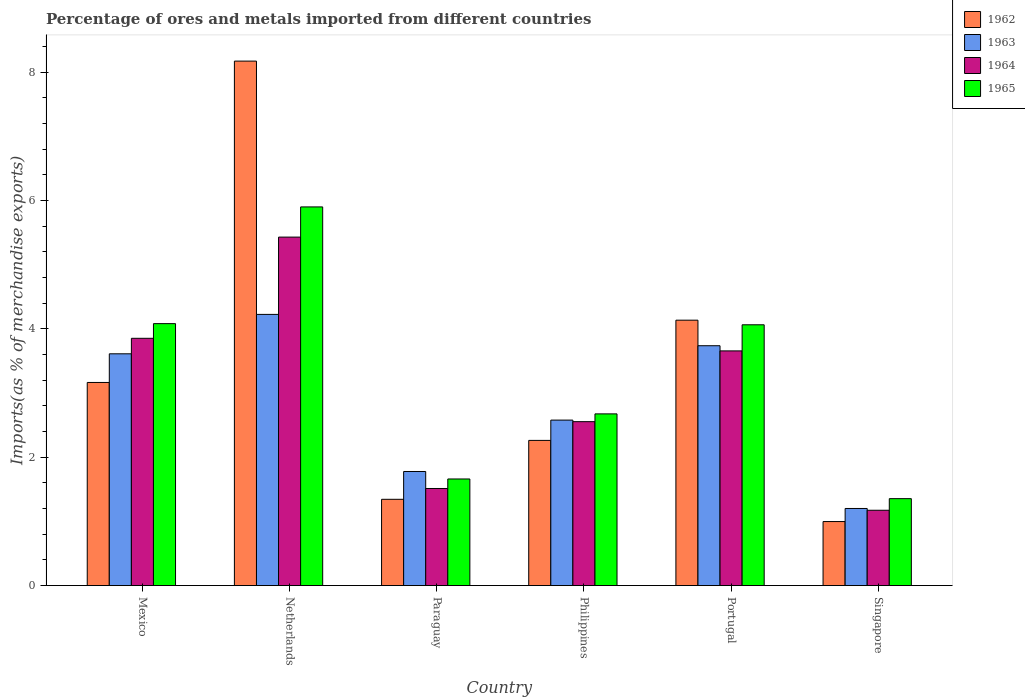How many groups of bars are there?
Your answer should be compact. 6. How many bars are there on the 2nd tick from the left?
Keep it short and to the point. 4. What is the label of the 6th group of bars from the left?
Keep it short and to the point. Singapore. What is the percentage of imports to different countries in 1963 in Mexico?
Your response must be concise. 3.61. Across all countries, what is the maximum percentage of imports to different countries in 1965?
Your answer should be compact. 5.9. Across all countries, what is the minimum percentage of imports to different countries in 1964?
Your answer should be compact. 1.17. In which country was the percentage of imports to different countries in 1965 maximum?
Keep it short and to the point. Netherlands. In which country was the percentage of imports to different countries in 1963 minimum?
Ensure brevity in your answer.  Singapore. What is the total percentage of imports to different countries in 1963 in the graph?
Keep it short and to the point. 17.13. What is the difference between the percentage of imports to different countries in 1964 in Mexico and that in Singapore?
Give a very brief answer. 2.68. What is the difference between the percentage of imports to different countries in 1965 in Netherlands and the percentage of imports to different countries in 1964 in Singapore?
Provide a succinct answer. 4.73. What is the average percentage of imports to different countries in 1965 per country?
Provide a succinct answer. 3.29. What is the difference between the percentage of imports to different countries of/in 1965 and percentage of imports to different countries of/in 1963 in Singapore?
Keep it short and to the point. 0.15. In how many countries, is the percentage of imports to different countries in 1963 greater than 6 %?
Give a very brief answer. 0. What is the ratio of the percentage of imports to different countries in 1964 in Paraguay to that in Singapore?
Make the answer very short. 1.29. Is the percentage of imports to different countries in 1963 in Mexico less than that in Portugal?
Your answer should be compact. Yes. Is the difference between the percentage of imports to different countries in 1965 in Philippines and Singapore greater than the difference between the percentage of imports to different countries in 1963 in Philippines and Singapore?
Make the answer very short. No. What is the difference between the highest and the second highest percentage of imports to different countries in 1964?
Give a very brief answer. -0.2. What is the difference between the highest and the lowest percentage of imports to different countries in 1962?
Make the answer very short. 7.17. What does the 2nd bar from the right in Paraguay represents?
Your response must be concise. 1964. How many bars are there?
Offer a very short reply. 24. Are all the bars in the graph horizontal?
Your answer should be compact. No. Where does the legend appear in the graph?
Offer a terse response. Top right. What is the title of the graph?
Give a very brief answer. Percentage of ores and metals imported from different countries. What is the label or title of the X-axis?
Your response must be concise. Country. What is the label or title of the Y-axis?
Keep it short and to the point. Imports(as % of merchandise exports). What is the Imports(as % of merchandise exports) of 1962 in Mexico?
Your answer should be very brief. 3.16. What is the Imports(as % of merchandise exports) in 1963 in Mexico?
Your response must be concise. 3.61. What is the Imports(as % of merchandise exports) of 1964 in Mexico?
Offer a terse response. 3.85. What is the Imports(as % of merchandise exports) in 1965 in Mexico?
Your response must be concise. 4.08. What is the Imports(as % of merchandise exports) in 1962 in Netherlands?
Give a very brief answer. 8.17. What is the Imports(as % of merchandise exports) in 1963 in Netherlands?
Provide a succinct answer. 4.22. What is the Imports(as % of merchandise exports) in 1964 in Netherlands?
Offer a very short reply. 5.43. What is the Imports(as % of merchandise exports) of 1965 in Netherlands?
Keep it short and to the point. 5.9. What is the Imports(as % of merchandise exports) of 1962 in Paraguay?
Provide a short and direct response. 1.34. What is the Imports(as % of merchandise exports) of 1963 in Paraguay?
Offer a very short reply. 1.78. What is the Imports(as % of merchandise exports) of 1964 in Paraguay?
Your answer should be very brief. 1.51. What is the Imports(as % of merchandise exports) of 1965 in Paraguay?
Your answer should be compact. 1.66. What is the Imports(as % of merchandise exports) of 1962 in Philippines?
Keep it short and to the point. 2.26. What is the Imports(as % of merchandise exports) of 1963 in Philippines?
Your answer should be compact. 2.58. What is the Imports(as % of merchandise exports) in 1964 in Philippines?
Make the answer very short. 2.55. What is the Imports(as % of merchandise exports) in 1965 in Philippines?
Provide a short and direct response. 2.67. What is the Imports(as % of merchandise exports) of 1962 in Portugal?
Your answer should be very brief. 4.13. What is the Imports(as % of merchandise exports) in 1963 in Portugal?
Offer a very short reply. 3.74. What is the Imports(as % of merchandise exports) of 1964 in Portugal?
Your answer should be very brief. 3.66. What is the Imports(as % of merchandise exports) in 1965 in Portugal?
Offer a very short reply. 4.06. What is the Imports(as % of merchandise exports) of 1962 in Singapore?
Offer a very short reply. 1. What is the Imports(as % of merchandise exports) of 1963 in Singapore?
Offer a very short reply. 1.2. What is the Imports(as % of merchandise exports) of 1964 in Singapore?
Give a very brief answer. 1.17. What is the Imports(as % of merchandise exports) in 1965 in Singapore?
Your answer should be compact. 1.35. Across all countries, what is the maximum Imports(as % of merchandise exports) of 1962?
Your response must be concise. 8.17. Across all countries, what is the maximum Imports(as % of merchandise exports) in 1963?
Provide a short and direct response. 4.22. Across all countries, what is the maximum Imports(as % of merchandise exports) of 1964?
Give a very brief answer. 5.43. Across all countries, what is the maximum Imports(as % of merchandise exports) in 1965?
Your answer should be very brief. 5.9. Across all countries, what is the minimum Imports(as % of merchandise exports) in 1962?
Ensure brevity in your answer.  1. Across all countries, what is the minimum Imports(as % of merchandise exports) of 1963?
Ensure brevity in your answer.  1.2. Across all countries, what is the minimum Imports(as % of merchandise exports) in 1964?
Keep it short and to the point. 1.17. Across all countries, what is the minimum Imports(as % of merchandise exports) of 1965?
Keep it short and to the point. 1.35. What is the total Imports(as % of merchandise exports) in 1962 in the graph?
Ensure brevity in your answer.  20.07. What is the total Imports(as % of merchandise exports) of 1963 in the graph?
Offer a terse response. 17.13. What is the total Imports(as % of merchandise exports) in 1964 in the graph?
Your answer should be very brief. 18.18. What is the total Imports(as % of merchandise exports) in 1965 in the graph?
Make the answer very short. 19.73. What is the difference between the Imports(as % of merchandise exports) of 1962 in Mexico and that in Netherlands?
Keep it short and to the point. -5.01. What is the difference between the Imports(as % of merchandise exports) of 1963 in Mexico and that in Netherlands?
Make the answer very short. -0.61. What is the difference between the Imports(as % of merchandise exports) of 1964 in Mexico and that in Netherlands?
Ensure brevity in your answer.  -1.58. What is the difference between the Imports(as % of merchandise exports) in 1965 in Mexico and that in Netherlands?
Your answer should be very brief. -1.82. What is the difference between the Imports(as % of merchandise exports) of 1962 in Mexico and that in Paraguay?
Offer a terse response. 1.82. What is the difference between the Imports(as % of merchandise exports) in 1963 in Mexico and that in Paraguay?
Your answer should be compact. 1.83. What is the difference between the Imports(as % of merchandise exports) in 1964 in Mexico and that in Paraguay?
Your response must be concise. 2.34. What is the difference between the Imports(as % of merchandise exports) in 1965 in Mexico and that in Paraguay?
Your answer should be very brief. 2.42. What is the difference between the Imports(as % of merchandise exports) in 1962 in Mexico and that in Philippines?
Ensure brevity in your answer.  0.9. What is the difference between the Imports(as % of merchandise exports) of 1963 in Mexico and that in Philippines?
Your answer should be compact. 1.03. What is the difference between the Imports(as % of merchandise exports) in 1964 in Mexico and that in Philippines?
Provide a short and direct response. 1.3. What is the difference between the Imports(as % of merchandise exports) in 1965 in Mexico and that in Philippines?
Make the answer very short. 1.41. What is the difference between the Imports(as % of merchandise exports) of 1962 in Mexico and that in Portugal?
Your answer should be compact. -0.97. What is the difference between the Imports(as % of merchandise exports) in 1963 in Mexico and that in Portugal?
Your answer should be compact. -0.13. What is the difference between the Imports(as % of merchandise exports) in 1964 in Mexico and that in Portugal?
Offer a very short reply. 0.2. What is the difference between the Imports(as % of merchandise exports) of 1965 in Mexico and that in Portugal?
Give a very brief answer. 0.02. What is the difference between the Imports(as % of merchandise exports) of 1962 in Mexico and that in Singapore?
Your answer should be very brief. 2.17. What is the difference between the Imports(as % of merchandise exports) of 1963 in Mexico and that in Singapore?
Give a very brief answer. 2.41. What is the difference between the Imports(as % of merchandise exports) of 1964 in Mexico and that in Singapore?
Your answer should be very brief. 2.68. What is the difference between the Imports(as % of merchandise exports) of 1965 in Mexico and that in Singapore?
Your answer should be very brief. 2.73. What is the difference between the Imports(as % of merchandise exports) of 1962 in Netherlands and that in Paraguay?
Provide a succinct answer. 6.83. What is the difference between the Imports(as % of merchandise exports) in 1963 in Netherlands and that in Paraguay?
Give a very brief answer. 2.45. What is the difference between the Imports(as % of merchandise exports) in 1964 in Netherlands and that in Paraguay?
Make the answer very short. 3.92. What is the difference between the Imports(as % of merchandise exports) in 1965 in Netherlands and that in Paraguay?
Your response must be concise. 4.24. What is the difference between the Imports(as % of merchandise exports) of 1962 in Netherlands and that in Philippines?
Your answer should be very brief. 5.91. What is the difference between the Imports(as % of merchandise exports) in 1963 in Netherlands and that in Philippines?
Give a very brief answer. 1.65. What is the difference between the Imports(as % of merchandise exports) of 1964 in Netherlands and that in Philippines?
Make the answer very short. 2.88. What is the difference between the Imports(as % of merchandise exports) of 1965 in Netherlands and that in Philippines?
Provide a short and direct response. 3.22. What is the difference between the Imports(as % of merchandise exports) of 1962 in Netherlands and that in Portugal?
Give a very brief answer. 4.04. What is the difference between the Imports(as % of merchandise exports) of 1963 in Netherlands and that in Portugal?
Ensure brevity in your answer.  0.49. What is the difference between the Imports(as % of merchandise exports) of 1964 in Netherlands and that in Portugal?
Make the answer very short. 1.77. What is the difference between the Imports(as % of merchandise exports) in 1965 in Netherlands and that in Portugal?
Make the answer very short. 1.84. What is the difference between the Imports(as % of merchandise exports) of 1962 in Netherlands and that in Singapore?
Offer a terse response. 7.17. What is the difference between the Imports(as % of merchandise exports) in 1963 in Netherlands and that in Singapore?
Your response must be concise. 3.02. What is the difference between the Imports(as % of merchandise exports) in 1964 in Netherlands and that in Singapore?
Make the answer very short. 4.26. What is the difference between the Imports(as % of merchandise exports) of 1965 in Netherlands and that in Singapore?
Provide a short and direct response. 4.55. What is the difference between the Imports(as % of merchandise exports) of 1962 in Paraguay and that in Philippines?
Provide a short and direct response. -0.92. What is the difference between the Imports(as % of merchandise exports) in 1963 in Paraguay and that in Philippines?
Keep it short and to the point. -0.8. What is the difference between the Imports(as % of merchandise exports) in 1964 in Paraguay and that in Philippines?
Your answer should be very brief. -1.04. What is the difference between the Imports(as % of merchandise exports) in 1965 in Paraguay and that in Philippines?
Your answer should be compact. -1.01. What is the difference between the Imports(as % of merchandise exports) of 1962 in Paraguay and that in Portugal?
Make the answer very short. -2.79. What is the difference between the Imports(as % of merchandise exports) in 1963 in Paraguay and that in Portugal?
Offer a terse response. -1.96. What is the difference between the Imports(as % of merchandise exports) in 1964 in Paraguay and that in Portugal?
Provide a short and direct response. -2.14. What is the difference between the Imports(as % of merchandise exports) of 1965 in Paraguay and that in Portugal?
Ensure brevity in your answer.  -2.4. What is the difference between the Imports(as % of merchandise exports) in 1962 in Paraguay and that in Singapore?
Ensure brevity in your answer.  0.35. What is the difference between the Imports(as % of merchandise exports) of 1963 in Paraguay and that in Singapore?
Your answer should be very brief. 0.58. What is the difference between the Imports(as % of merchandise exports) of 1964 in Paraguay and that in Singapore?
Your response must be concise. 0.34. What is the difference between the Imports(as % of merchandise exports) of 1965 in Paraguay and that in Singapore?
Offer a very short reply. 0.31. What is the difference between the Imports(as % of merchandise exports) of 1962 in Philippines and that in Portugal?
Provide a short and direct response. -1.87. What is the difference between the Imports(as % of merchandise exports) in 1963 in Philippines and that in Portugal?
Ensure brevity in your answer.  -1.16. What is the difference between the Imports(as % of merchandise exports) of 1964 in Philippines and that in Portugal?
Offer a very short reply. -1.1. What is the difference between the Imports(as % of merchandise exports) in 1965 in Philippines and that in Portugal?
Offer a very short reply. -1.39. What is the difference between the Imports(as % of merchandise exports) of 1962 in Philippines and that in Singapore?
Offer a terse response. 1.26. What is the difference between the Imports(as % of merchandise exports) of 1963 in Philippines and that in Singapore?
Offer a terse response. 1.38. What is the difference between the Imports(as % of merchandise exports) of 1964 in Philippines and that in Singapore?
Provide a short and direct response. 1.38. What is the difference between the Imports(as % of merchandise exports) of 1965 in Philippines and that in Singapore?
Give a very brief answer. 1.32. What is the difference between the Imports(as % of merchandise exports) in 1962 in Portugal and that in Singapore?
Offer a very short reply. 3.14. What is the difference between the Imports(as % of merchandise exports) of 1963 in Portugal and that in Singapore?
Your answer should be compact. 2.54. What is the difference between the Imports(as % of merchandise exports) in 1964 in Portugal and that in Singapore?
Offer a very short reply. 2.48. What is the difference between the Imports(as % of merchandise exports) in 1965 in Portugal and that in Singapore?
Your response must be concise. 2.71. What is the difference between the Imports(as % of merchandise exports) in 1962 in Mexico and the Imports(as % of merchandise exports) in 1963 in Netherlands?
Your response must be concise. -1.06. What is the difference between the Imports(as % of merchandise exports) in 1962 in Mexico and the Imports(as % of merchandise exports) in 1964 in Netherlands?
Make the answer very short. -2.26. What is the difference between the Imports(as % of merchandise exports) of 1962 in Mexico and the Imports(as % of merchandise exports) of 1965 in Netherlands?
Your answer should be compact. -2.73. What is the difference between the Imports(as % of merchandise exports) of 1963 in Mexico and the Imports(as % of merchandise exports) of 1964 in Netherlands?
Your response must be concise. -1.82. What is the difference between the Imports(as % of merchandise exports) of 1963 in Mexico and the Imports(as % of merchandise exports) of 1965 in Netherlands?
Offer a terse response. -2.29. What is the difference between the Imports(as % of merchandise exports) of 1964 in Mexico and the Imports(as % of merchandise exports) of 1965 in Netherlands?
Your answer should be very brief. -2.05. What is the difference between the Imports(as % of merchandise exports) of 1962 in Mexico and the Imports(as % of merchandise exports) of 1963 in Paraguay?
Keep it short and to the point. 1.39. What is the difference between the Imports(as % of merchandise exports) in 1962 in Mexico and the Imports(as % of merchandise exports) in 1964 in Paraguay?
Your answer should be compact. 1.65. What is the difference between the Imports(as % of merchandise exports) of 1962 in Mexico and the Imports(as % of merchandise exports) of 1965 in Paraguay?
Make the answer very short. 1.5. What is the difference between the Imports(as % of merchandise exports) in 1963 in Mexico and the Imports(as % of merchandise exports) in 1964 in Paraguay?
Give a very brief answer. 2.1. What is the difference between the Imports(as % of merchandise exports) in 1963 in Mexico and the Imports(as % of merchandise exports) in 1965 in Paraguay?
Your answer should be compact. 1.95. What is the difference between the Imports(as % of merchandise exports) of 1964 in Mexico and the Imports(as % of merchandise exports) of 1965 in Paraguay?
Provide a succinct answer. 2.19. What is the difference between the Imports(as % of merchandise exports) of 1962 in Mexico and the Imports(as % of merchandise exports) of 1963 in Philippines?
Keep it short and to the point. 0.59. What is the difference between the Imports(as % of merchandise exports) of 1962 in Mexico and the Imports(as % of merchandise exports) of 1964 in Philippines?
Provide a succinct answer. 0.61. What is the difference between the Imports(as % of merchandise exports) in 1962 in Mexico and the Imports(as % of merchandise exports) in 1965 in Philippines?
Make the answer very short. 0.49. What is the difference between the Imports(as % of merchandise exports) in 1963 in Mexico and the Imports(as % of merchandise exports) in 1964 in Philippines?
Keep it short and to the point. 1.06. What is the difference between the Imports(as % of merchandise exports) of 1963 in Mexico and the Imports(as % of merchandise exports) of 1965 in Philippines?
Give a very brief answer. 0.94. What is the difference between the Imports(as % of merchandise exports) in 1964 in Mexico and the Imports(as % of merchandise exports) in 1965 in Philippines?
Make the answer very short. 1.18. What is the difference between the Imports(as % of merchandise exports) of 1962 in Mexico and the Imports(as % of merchandise exports) of 1963 in Portugal?
Give a very brief answer. -0.57. What is the difference between the Imports(as % of merchandise exports) of 1962 in Mexico and the Imports(as % of merchandise exports) of 1964 in Portugal?
Provide a short and direct response. -0.49. What is the difference between the Imports(as % of merchandise exports) in 1962 in Mexico and the Imports(as % of merchandise exports) in 1965 in Portugal?
Your response must be concise. -0.9. What is the difference between the Imports(as % of merchandise exports) of 1963 in Mexico and the Imports(as % of merchandise exports) of 1964 in Portugal?
Provide a short and direct response. -0.05. What is the difference between the Imports(as % of merchandise exports) in 1963 in Mexico and the Imports(as % of merchandise exports) in 1965 in Portugal?
Make the answer very short. -0.45. What is the difference between the Imports(as % of merchandise exports) in 1964 in Mexico and the Imports(as % of merchandise exports) in 1965 in Portugal?
Your response must be concise. -0.21. What is the difference between the Imports(as % of merchandise exports) in 1962 in Mexico and the Imports(as % of merchandise exports) in 1963 in Singapore?
Your answer should be very brief. 1.96. What is the difference between the Imports(as % of merchandise exports) in 1962 in Mexico and the Imports(as % of merchandise exports) in 1964 in Singapore?
Offer a very short reply. 1.99. What is the difference between the Imports(as % of merchandise exports) of 1962 in Mexico and the Imports(as % of merchandise exports) of 1965 in Singapore?
Offer a terse response. 1.81. What is the difference between the Imports(as % of merchandise exports) of 1963 in Mexico and the Imports(as % of merchandise exports) of 1964 in Singapore?
Offer a terse response. 2.44. What is the difference between the Imports(as % of merchandise exports) of 1963 in Mexico and the Imports(as % of merchandise exports) of 1965 in Singapore?
Ensure brevity in your answer.  2.26. What is the difference between the Imports(as % of merchandise exports) in 1964 in Mexico and the Imports(as % of merchandise exports) in 1965 in Singapore?
Ensure brevity in your answer.  2.5. What is the difference between the Imports(as % of merchandise exports) in 1962 in Netherlands and the Imports(as % of merchandise exports) in 1963 in Paraguay?
Offer a terse response. 6.39. What is the difference between the Imports(as % of merchandise exports) in 1962 in Netherlands and the Imports(as % of merchandise exports) in 1964 in Paraguay?
Provide a succinct answer. 6.66. What is the difference between the Imports(as % of merchandise exports) in 1962 in Netherlands and the Imports(as % of merchandise exports) in 1965 in Paraguay?
Provide a short and direct response. 6.51. What is the difference between the Imports(as % of merchandise exports) in 1963 in Netherlands and the Imports(as % of merchandise exports) in 1964 in Paraguay?
Offer a terse response. 2.71. What is the difference between the Imports(as % of merchandise exports) in 1963 in Netherlands and the Imports(as % of merchandise exports) in 1965 in Paraguay?
Make the answer very short. 2.56. What is the difference between the Imports(as % of merchandise exports) in 1964 in Netherlands and the Imports(as % of merchandise exports) in 1965 in Paraguay?
Keep it short and to the point. 3.77. What is the difference between the Imports(as % of merchandise exports) in 1962 in Netherlands and the Imports(as % of merchandise exports) in 1963 in Philippines?
Your answer should be very brief. 5.59. What is the difference between the Imports(as % of merchandise exports) in 1962 in Netherlands and the Imports(as % of merchandise exports) in 1964 in Philippines?
Provide a succinct answer. 5.62. What is the difference between the Imports(as % of merchandise exports) of 1962 in Netherlands and the Imports(as % of merchandise exports) of 1965 in Philippines?
Offer a very short reply. 5.5. What is the difference between the Imports(as % of merchandise exports) of 1963 in Netherlands and the Imports(as % of merchandise exports) of 1964 in Philippines?
Offer a very short reply. 1.67. What is the difference between the Imports(as % of merchandise exports) of 1963 in Netherlands and the Imports(as % of merchandise exports) of 1965 in Philippines?
Offer a very short reply. 1.55. What is the difference between the Imports(as % of merchandise exports) of 1964 in Netherlands and the Imports(as % of merchandise exports) of 1965 in Philippines?
Your answer should be compact. 2.75. What is the difference between the Imports(as % of merchandise exports) in 1962 in Netherlands and the Imports(as % of merchandise exports) in 1963 in Portugal?
Give a very brief answer. 4.43. What is the difference between the Imports(as % of merchandise exports) in 1962 in Netherlands and the Imports(as % of merchandise exports) in 1964 in Portugal?
Your response must be concise. 4.51. What is the difference between the Imports(as % of merchandise exports) of 1962 in Netherlands and the Imports(as % of merchandise exports) of 1965 in Portugal?
Your response must be concise. 4.11. What is the difference between the Imports(as % of merchandise exports) in 1963 in Netherlands and the Imports(as % of merchandise exports) in 1964 in Portugal?
Your answer should be very brief. 0.57. What is the difference between the Imports(as % of merchandise exports) in 1963 in Netherlands and the Imports(as % of merchandise exports) in 1965 in Portugal?
Your answer should be very brief. 0.16. What is the difference between the Imports(as % of merchandise exports) of 1964 in Netherlands and the Imports(as % of merchandise exports) of 1965 in Portugal?
Make the answer very short. 1.37. What is the difference between the Imports(as % of merchandise exports) of 1962 in Netherlands and the Imports(as % of merchandise exports) of 1963 in Singapore?
Your answer should be very brief. 6.97. What is the difference between the Imports(as % of merchandise exports) of 1962 in Netherlands and the Imports(as % of merchandise exports) of 1964 in Singapore?
Give a very brief answer. 7. What is the difference between the Imports(as % of merchandise exports) in 1962 in Netherlands and the Imports(as % of merchandise exports) in 1965 in Singapore?
Ensure brevity in your answer.  6.82. What is the difference between the Imports(as % of merchandise exports) of 1963 in Netherlands and the Imports(as % of merchandise exports) of 1964 in Singapore?
Ensure brevity in your answer.  3.05. What is the difference between the Imports(as % of merchandise exports) in 1963 in Netherlands and the Imports(as % of merchandise exports) in 1965 in Singapore?
Your answer should be compact. 2.87. What is the difference between the Imports(as % of merchandise exports) of 1964 in Netherlands and the Imports(as % of merchandise exports) of 1965 in Singapore?
Provide a short and direct response. 4.07. What is the difference between the Imports(as % of merchandise exports) of 1962 in Paraguay and the Imports(as % of merchandise exports) of 1963 in Philippines?
Make the answer very short. -1.23. What is the difference between the Imports(as % of merchandise exports) of 1962 in Paraguay and the Imports(as % of merchandise exports) of 1964 in Philippines?
Your answer should be very brief. -1.21. What is the difference between the Imports(as % of merchandise exports) of 1962 in Paraguay and the Imports(as % of merchandise exports) of 1965 in Philippines?
Give a very brief answer. -1.33. What is the difference between the Imports(as % of merchandise exports) of 1963 in Paraguay and the Imports(as % of merchandise exports) of 1964 in Philippines?
Your response must be concise. -0.78. What is the difference between the Imports(as % of merchandise exports) of 1963 in Paraguay and the Imports(as % of merchandise exports) of 1965 in Philippines?
Provide a short and direct response. -0.9. What is the difference between the Imports(as % of merchandise exports) in 1964 in Paraguay and the Imports(as % of merchandise exports) in 1965 in Philippines?
Make the answer very short. -1.16. What is the difference between the Imports(as % of merchandise exports) in 1962 in Paraguay and the Imports(as % of merchandise exports) in 1963 in Portugal?
Your answer should be compact. -2.39. What is the difference between the Imports(as % of merchandise exports) of 1962 in Paraguay and the Imports(as % of merchandise exports) of 1964 in Portugal?
Make the answer very short. -2.31. What is the difference between the Imports(as % of merchandise exports) in 1962 in Paraguay and the Imports(as % of merchandise exports) in 1965 in Portugal?
Your response must be concise. -2.72. What is the difference between the Imports(as % of merchandise exports) in 1963 in Paraguay and the Imports(as % of merchandise exports) in 1964 in Portugal?
Ensure brevity in your answer.  -1.88. What is the difference between the Imports(as % of merchandise exports) in 1963 in Paraguay and the Imports(as % of merchandise exports) in 1965 in Portugal?
Provide a short and direct response. -2.29. What is the difference between the Imports(as % of merchandise exports) in 1964 in Paraguay and the Imports(as % of merchandise exports) in 1965 in Portugal?
Your answer should be very brief. -2.55. What is the difference between the Imports(as % of merchandise exports) of 1962 in Paraguay and the Imports(as % of merchandise exports) of 1963 in Singapore?
Offer a terse response. 0.14. What is the difference between the Imports(as % of merchandise exports) in 1962 in Paraguay and the Imports(as % of merchandise exports) in 1964 in Singapore?
Ensure brevity in your answer.  0.17. What is the difference between the Imports(as % of merchandise exports) of 1962 in Paraguay and the Imports(as % of merchandise exports) of 1965 in Singapore?
Provide a succinct answer. -0.01. What is the difference between the Imports(as % of merchandise exports) of 1963 in Paraguay and the Imports(as % of merchandise exports) of 1964 in Singapore?
Your response must be concise. 0.6. What is the difference between the Imports(as % of merchandise exports) in 1963 in Paraguay and the Imports(as % of merchandise exports) in 1965 in Singapore?
Ensure brevity in your answer.  0.42. What is the difference between the Imports(as % of merchandise exports) in 1964 in Paraguay and the Imports(as % of merchandise exports) in 1965 in Singapore?
Offer a very short reply. 0.16. What is the difference between the Imports(as % of merchandise exports) of 1962 in Philippines and the Imports(as % of merchandise exports) of 1963 in Portugal?
Your response must be concise. -1.47. What is the difference between the Imports(as % of merchandise exports) in 1962 in Philippines and the Imports(as % of merchandise exports) in 1964 in Portugal?
Your answer should be very brief. -1.39. What is the difference between the Imports(as % of merchandise exports) of 1962 in Philippines and the Imports(as % of merchandise exports) of 1965 in Portugal?
Provide a succinct answer. -1.8. What is the difference between the Imports(as % of merchandise exports) of 1963 in Philippines and the Imports(as % of merchandise exports) of 1964 in Portugal?
Give a very brief answer. -1.08. What is the difference between the Imports(as % of merchandise exports) in 1963 in Philippines and the Imports(as % of merchandise exports) in 1965 in Portugal?
Your response must be concise. -1.48. What is the difference between the Imports(as % of merchandise exports) in 1964 in Philippines and the Imports(as % of merchandise exports) in 1965 in Portugal?
Make the answer very short. -1.51. What is the difference between the Imports(as % of merchandise exports) of 1962 in Philippines and the Imports(as % of merchandise exports) of 1963 in Singapore?
Offer a very short reply. 1.06. What is the difference between the Imports(as % of merchandise exports) of 1962 in Philippines and the Imports(as % of merchandise exports) of 1964 in Singapore?
Ensure brevity in your answer.  1.09. What is the difference between the Imports(as % of merchandise exports) of 1962 in Philippines and the Imports(as % of merchandise exports) of 1965 in Singapore?
Make the answer very short. 0.91. What is the difference between the Imports(as % of merchandise exports) of 1963 in Philippines and the Imports(as % of merchandise exports) of 1964 in Singapore?
Your answer should be very brief. 1.4. What is the difference between the Imports(as % of merchandise exports) in 1963 in Philippines and the Imports(as % of merchandise exports) in 1965 in Singapore?
Your answer should be very brief. 1.22. What is the difference between the Imports(as % of merchandise exports) in 1964 in Philippines and the Imports(as % of merchandise exports) in 1965 in Singapore?
Your answer should be compact. 1.2. What is the difference between the Imports(as % of merchandise exports) of 1962 in Portugal and the Imports(as % of merchandise exports) of 1963 in Singapore?
Ensure brevity in your answer.  2.93. What is the difference between the Imports(as % of merchandise exports) in 1962 in Portugal and the Imports(as % of merchandise exports) in 1964 in Singapore?
Your response must be concise. 2.96. What is the difference between the Imports(as % of merchandise exports) of 1962 in Portugal and the Imports(as % of merchandise exports) of 1965 in Singapore?
Ensure brevity in your answer.  2.78. What is the difference between the Imports(as % of merchandise exports) of 1963 in Portugal and the Imports(as % of merchandise exports) of 1964 in Singapore?
Give a very brief answer. 2.56. What is the difference between the Imports(as % of merchandise exports) in 1963 in Portugal and the Imports(as % of merchandise exports) in 1965 in Singapore?
Offer a very short reply. 2.38. What is the difference between the Imports(as % of merchandise exports) of 1964 in Portugal and the Imports(as % of merchandise exports) of 1965 in Singapore?
Offer a very short reply. 2.3. What is the average Imports(as % of merchandise exports) of 1962 per country?
Keep it short and to the point. 3.35. What is the average Imports(as % of merchandise exports) of 1963 per country?
Make the answer very short. 2.85. What is the average Imports(as % of merchandise exports) in 1964 per country?
Your answer should be very brief. 3.03. What is the average Imports(as % of merchandise exports) in 1965 per country?
Give a very brief answer. 3.29. What is the difference between the Imports(as % of merchandise exports) in 1962 and Imports(as % of merchandise exports) in 1963 in Mexico?
Keep it short and to the point. -0.45. What is the difference between the Imports(as % of merchandise exports) in 1962 and Imports(as % of merchandise exports) in 1964 in Mexico?
Provide a short and direct response. -0.69. What is the difference between the Imports(as % of merchandise exports) of 1962 and Imports(as % of merchandise exports) of 1965 in Mexico?
Your answer should be compact. -0.92. What is the difference between the Imports(as % of merchandise exports) in 1963 and Imports(as % of merchandise exports) in 1964 in Mexico?
Your answer should be compact. -0.24. What is the difference between the Imports(as % of merchandise exports) in 1963 and Imports(as % of merchandise exports) in 1965 in Mexico?
Ensure brevity in your answer.  -0.47. What is the difference between the Imports(as % of merchandise exports) of 1964 and Imports(as % of merchandise exports) of 1965 in Mexico?
Your response must be concise. -0.23. What is the difference between the Imports(as % of merchandise exports) in 1962 and Imports(as % of merchandise exports) in 1963 in Netherlands?
Your answer should be very brief. 3.95. What is the difference between the Imports(as % of merchandise exports) in 1962 and Imports(as % of merchandise exports) in 1964 in Netherlands?
Make the answer very short. 2.74. What is the difference between the Imports(as % of merchandise exports) in 1962 and Imports(as % of merchandise exports) in 1965 in Netherlands?
Your answer should be very brief. 2.27. What is the difference between the Imports(as % of merchandise exports) of 1963 and Imports(as % of merchandise exports) of 1964 in Netherlands?
Give a very brief answer. -1.2. What is the difference between the Imports(as % of merchandise exports) in 1963 and Imports(as % of merchandise exports) in 1965 in Netherlands?
Offer a terse response. -1.67. What is the difference between the Imports(as % of merchandise exports) in 1964 and Imports(as % of merchandise exports) in 1965 in Netherlands?
Make the answer very short. -0.47. What is the difference between the Imports(as % of merchandise exports) of 1962 and Imports(as % of merchandise exports) of 1963 in Paraguay?
Your answer should be very brief. -0.43. What is the difference between the Imports(as % of merchandise exports) of 1962 and Imports(as % of merchandise exports) of 1964 in Paraguay?
Make the answer very short. -0.17. What is the difference between the Imports(as % of merchandise exports) in 1962 and Imports(as % of merchandise exports) in 1965 in Paraguay?
Provide a succinct answer. -0.32. What is the difference between the Imports(as % of merchandise exports) of 1963 and Imports(as % of merchandise exports) of 1964 in Paraguay?
Offer a terse response. 0.26. What is the difference between the Imports(as % of merchandise exports) of 1963 and Imports(as % of merchandise exports) of 1965 in Paraguay?
Provide a short and direct response. 0.12. What is the difference between the Imports(as % of merchandise exports) in 1964 and Imports(as % of merchandise exports) in 1965 in Paraguay?
Your answer should be very brief. -0.15. What is the difference between the Imports(as % of merchandise exports) of 1962 and Imports(as % of merchandise exports) of 1963 in Philippines?
Offer a very short reply. -0.32. What is the difference between the Imports(as % of merchandise exports) in 1962 and Imports(as % of merchandise exports) in 1964 in Philippines?
Your answer should be very brief. -0.29. What is the difference between the Imports(as % of merchandise exports) in 1962 and Imports(as % of merchandise exports) in 1965 in Philippines?
Your response must be concise. -0.41. What is the difference between the Imports(as % of merchandise exports) in 1963 and Imports(as % of merchandise exports) in 1964 in Philippines?
Keep it short and to the point. 0.02. What is the difference between the Imports(as % of merchandise exports) in 1963 and Imports(as % of merchandise exports) in 1965 in Philippines?
Offer a terse response. -0.1. What is the difference between the Imports(as % of merchandise exports) in 1964 and Imports(as % of merchandise exports) in 1965 in Philippines?
Your response must be concise. -0.12. What is the difference between the Imports(as % of merchandise exports) of 1962 and Imports(as % of merchandise exports) of 1963 in Portugal?
Ensure brevity in your answer.  0.4. What is the difference between the Imports(as % of merchandise exports) of 1962 and Imports(as % of merchandise exports) of 1964 in Portugal?
Provide a short and direct response. 0.48. What is the difference between the Imports(as % of merchandise exports) in 1962 and Imports(as % of merchandise exports) in 1965 in Portugal?
Make the answer very short. 0.07. What is the difference between the Imports(as % of merchandise exports) in 1963 and Imports(as % of merchandise exports) in 1964 in Portugal?
Keep it short and to the point. 0.08. What is the difference between the Imports(as % of merchandise exports) of 1963 and Imports(as % of merchandise exports) of 1965 in Portugal?
Offer a very short reply. -0.33. What is the difference between the Imports(as % of merchandise exports) in 1964 and Imports(as % of merchandise exports) in 1965 in Portugal?
Your answer should be very brief. -0.41. What is the difference between the Imports(as % of merchandise exports) in 1962 and Imports(as % of merchandise exports) in 1963 in Singapore?
Keep it short and to the point. -0.2. What is the difference between the Imports(as % of merchandise exports) of 1962 and Imports(as % of merchandise exports) of 1964 in Singapore?
Your answer should be compact. -0.18. What is the difference between the Imports(as % of merchandise exports) of 1962 and Imports(as % of merchandise exports) of 1965 in Singapore?
Provide a succinct answer. -0.36. What is the difference between the Imports(as % of merchandise exports) of 1963 and Imports(as % of merchandise exports) of 1964 in Singapore?
Make the answer very short. 0.03. What is the difference between the Imports(as % of merchandise exports) of 1963 and Imports(as % of merchandise exports) of 1965 in Singapore?
Your response must be concise. -0.15. What is the difference between the Imports(as % of merchandise exports) in 1964 and Imports(as % of merchandise exports) in 1965 in Singapore?
Make the answer very short. -0.18. What is the ratio of the Imports(as % of merchandise exports) in 1962 in Mexico to that in Netherlands?
Your answer should be compact. 0.39. What is the ratio of the Imports(as % of merchandise exports) of 1963 in Mexico to that in Netherlands?
Your answer should be compact. 0.85. What is the ratio of the Imports(as % of merchandise exports) of 1964 in Mexico to that in Netherlands?
Your answer should be compact. 0.71. What is the ratio of the Imports(as % of merchandise exports) of 1965 in Mexico to that in Netherlands?
Make the answer very short. 0.69. What is the ratio of the Imports(as % of merchandise exports) in 1962 in Mexico to that in Paraguay?
Keep it short and to the point. 2.35. What is the ratio of the Imports(as % of merchandise exports) of 1963 in Mexico to that in Paraguay?
Your response must be concise. 2.03. What is the ratio of the Imports(as % of merchandise exports) of 1964 in Mexico to that in Paraguay?
Give a very brief answer. 2.55. What is the ratio of the Imports(as % of merchandise exports) in 1965 in Mexico to that in Paraguay?
Provide a short and direct response. 2.46. What is the ratio of the Imports(as % of merchandise exports) in 1962 in Mexico to that in Philippines?
Your answer should be very brief. 1.4. What is the ratio of the Imports(as % of merchandise exports) in 1963 in Mexico to that in Philippines?
Your response must be concise. 1.4. What is the ratio of the Imports(as % of merchandise exports) in 1964 in Mexico to that in Philippines?
Provide a succinct answer. 1.51. What is the ratio of the Imports(as % of merchandise exports) in 1965 in Mexico to that in Philippines?
Give a very brief answer. 1.53. What is the ratio of the Imports(as % of merchandise exports) of 1962 in Mexico to that in Portugal?
Provide a short and direct response. 0.77. What is the ratio of the Imports(as % of merchandise exports) in 1963 in Mexico to that in Portugal?
Provide a succinct answer. 0.97. What is the ratio of the Imports(as % of merchandise exports) of 1964 in Mexico to that in Portugal?
Provide a short and direct response. 1.05. What is the ratio of the Imports(as % of merchandise exports) of 1962 in Mexico to that in Singapore?
Ensure brevity in your answer.  3.17. What is the ratio of the Imports(as % of merchandise exports) of 1963 in Mexico to that in Singapore?
Make the answer very short. 3.01. What is the ratio of the Imports(as % of merchandise exports) in 1964 in Mexico to that in Singapore?
Keep it short and to the point. 3.28. What is the ratio of the Imports(as % of merchandise exports) in 1965 in Mexico to that in Singapore?
Your answer should be very brief. 3.01. What is the ratio of the Imports(as % of merchandise exports) of 1962 in Netherlands to that in Paraguay?
Ensure brevity in your answer.  6.08. What is the ratio of the Imports(as % of merchandise exports) in 1963 in Netherlands to that in Paraguay?
Provide a succinct answer. 2.38. What is the ratio of the Imports(as % of merchandise exports) in 1964 in Netherlands to that in Paraguay?
Your response must be concise. 3.59. What is the ratio of the Imports(as % of merchandise exports) of 1965 in Netherlands to that in Paraguay?
Your answer should be very brief. 3.55. What is the ratio of the Imports(as % of merchandise exports) of 1962 in Netherlands to that in Philippines?
Your answer should be very brief. 3.61. What is the ratio of the Imports(as % of merchandise exports) in 1963 in Netherlands to that in Philippines?
Your answer should be very brief. 1.64. What is the ratio of the Imports(as % of merchandise exports) of 1964 in Netherlands to that in Philippines?
Offer a terse response. 2.13. What is the ratio of the Imports(as % of merchandise exports) in 1965 in Netherlands to that in Philippines?
Your answer should be compact. 2.21. What is the ratio of the Imports(as % of merchandise exports) in 1962 in Netherlands to that in Portugal?
Your answer should be very brief. 1.98. What is the ratio of the Imports(as % of merchandise exports) in 1963 in Netherlands to that in Portugal?
Make the answer very short. 1.13. What is the ratio of the Imports(as % of merchandise exports) in 1964 in Netherlands to that in Portugal?
Make the answer very short. 1.49. What is the ratio of the Imports(as % of merchandise exports) of 1965 in Netherlands to that in Portugal?
Your response must be concise. 1.45. What is the ratio of the Imports(as % of merchandise exports) in 1962 in Netherlands to that in Singapore?
Your answer should be very brief. 8.19. What is the ratio of the Imports(as % of merchandise exports) in 1963 in Netherlands to that in Singapore?
Offer a very short reply. 3.52. What is the ratio of the Imports(as % of merchandise exports) in 1964 in Netherlands to that in Singapore?
Make the answer very short. 4.63. What is the ratio of the Imports(as % of merchandise exports) in 1965 in Netherlands to that in Singapore?
Keep it short and to the point. 4.36. What is the ratio of the Imports(as % of merchandise exports) in 1962 in Paraguay to that in Philippines?
Provide a succinct answer. 0.59. What is the ratio of the Imports(as % of merchandise exports) of 1963 in Paraguay to that in Philippines?
Your answer should be very brief. 0.69. What is the ratio of the Imports(as % of merchandise exports) in 1964 in Paraguay to that in Philippines?
Your answer should be very brief. 0.59. What is the ratio of the Imports(as % of merchandise exports) in 1965 in Paraguay to that in Philippines?
Your response must be concise. 0.62. What is the ratio of the Imports(as % of merchandise exports) in 1962 in Paraguay to that in Portugal?
Ensure brevity in your answer.  0.33. What is the ratio of the Imports(as % of merchandise exports) in 1963 in Paraguay to that in Portugal?
Your response must be concise. 0.48. What is the ratio of the Imports(as % of merchandise exports) of 1964 in Paraguay to that in Portugal?
Give a very brief answer. 0.41. What is the ratio of the Imports(as % of merchandise exports) in 1965 in Paraguay to that in Portugal?
Keep it short and to the point. 0.41. What is the ratio of the Imports(as % of merchandise exports) of 1962 in Paraguay to that in Singapore?
Your answer should be compact. 1.35. What is the ratio of the Imports(as % of merchandise exports) of 1963 in Paraguay to that in Singapore?
Your response must be concise. 1.48. What is the ratio of the Imports(as % of merchandise exports) in 1964 in Paraguay to that in Singapore?
Your answer should be very brief. 1.29. What is the ratio of the Imports(as % of merchandise exports) of 1965 in Paraguay to that in Singapore?
Offer a very short reply. 1.23. What is the ratio of the Imports(as % of merchandise exports) in 1962 in Philippines to that in Portugal?
Provide a succinct answer. 0.55. What is the ratio of the Imports(as % of merchandise exports) of 1963 in Philippines to that in Portugal?
Your response must be concise. 0.69. What is the ratio of the Imports(as % of merchandise exports) in 1964 in Philippines to that in Portugal?
Provide a short and direct response. 0.7. What is the ratio of the Imports(as % of merchandise exports) in 1965 in Philippines to that in Portugal?
Provide a short and direct response. 0.66. What is the ratio of the Imports(as % of merchandise exports) of 1962 in Philippines to that in Singapore?
Keep it short and to the point. 2.27. What is the ratio of the Imports(as % of merchandise exports) of 1963 in Philippines to that in Singapore?
Offer a terse response. 2.15. What is the ratio of the Imports(as % of merchandise exports) of 1964 in Philippines to that in Singapore?
Keep it short and to the point. 2.18. What is the ratio of the Imports(as % of merchandise exports) in 1965 in Philippines to that in Singapore?
Keep it short and to the point. 1.98. What is the ratio of the Imports(as % of merchandise exports) of 1962 in Portugal to that in Singapore?
Make the answer very short. 4.15. What is the ratio of the Imports(as % of merchandise exports) in 1963 in Portugal to that in Singapore?
Offer a very short reply. 3.11. What is the ratio of the Imports(as % of merchandise exports) in 1964 in Portugal to that in Singapore?
Provide a short and direct response. 3.12. What is the ratio of the Imports(as % of merchandise exports) of 1965 in Portugal to that in Singapore?
Provide a short and direct response. 3. What is the difference between the highest and the second highest Imports(as % of merchandise exports) in 1962?
Keep it short and to the point. 4.04. What is the difference between the highest and the second highest Imports(as % of merchandise exports) in 1963?
Ensure brevity in your answer.  0.49. What is the difference between the highest and the second highest Imports(as % of merchandise exports) of 1964?
Offer a terse response. 1.58. What is the difference between the highest and the second highest Imports(as % of merchandise exports) of 1965?
Your answer should be compact. 1.82. What is the difference between the highest and the lowest Imports(as % of merchandise exports) of 1962?
Keep it short and to the point. 7.17. What is the difference between the highest and the lowest Imports(as % of merchandise exports) of 1963?
Offer a terse response. 3.02. What is the difference between the highest and the lowest Imports(as % of merchandise exports) in 1964?
Keep it short and to the point. 4.26. What is the difference between the highest and the lowest Imports(as % of merchandise exports) in 1965?
Give a very brief answer. 4.55. 